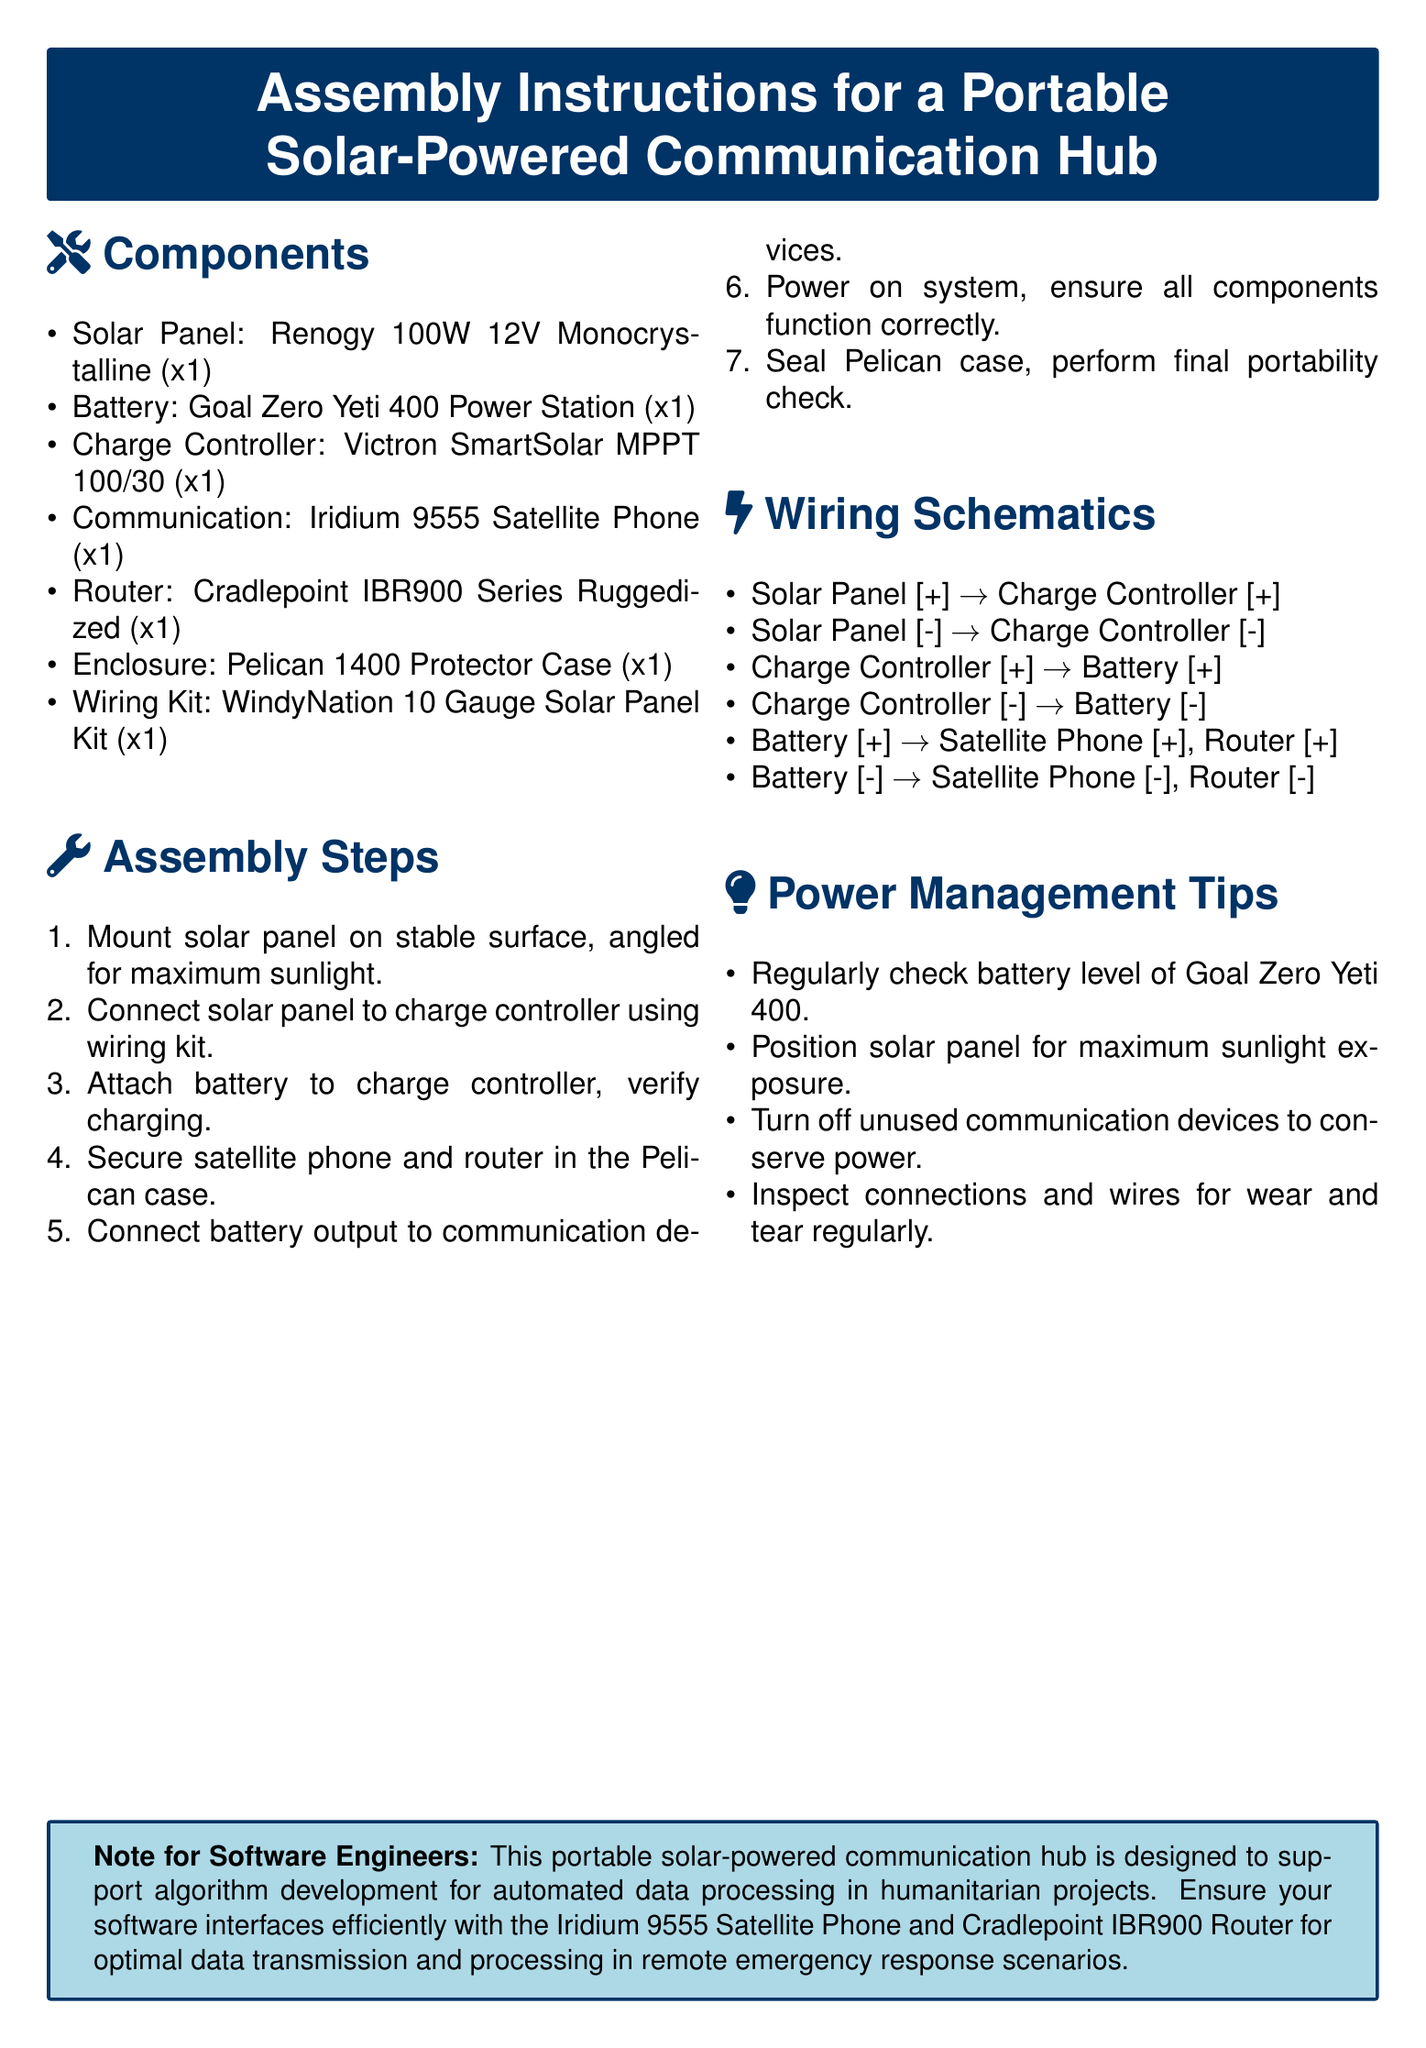What size is the solar panel used? The solar panel mentioned in the document is a 100W 12V Monocrystalline model.
Answer: 100W 12V Monocrystalline How many components are listed for assembly? The document lists a total of seven components necessary for the assembly of the hub.
Answer: 7 What is the model of the charge controller? The charge controller used in the assembly instructions is the Victron SmartSolar MPPT.
Answer: Victron SmartSolar MPPT 100/30 What should be checked regularly for power management? One of the power management tips specifies that the battery level should be checked regularly.
Answer: Battery level What device must be secured in the Pelican case? The instructions specifically mention securing the satellite phone and router in the Pelican case during assembly.
Answer: Satellite phone and router Which device connects directly to the battery output? The document states that both the satellite phone and the router are connected to the battery output.
Answer: Satellite phone and router What is the purpose of positioning the solar panel correctly? The power management tips highlight the importance of positioning the solar panel for maximum sunlight exposure to optimize charging.
Answer: Maximum sunlight exposure What type of case is used for the portable hub? The assembly instructions specify using a Pelican Protector Case for housing the components.
Answer: Pelican 1400 Protector Case 